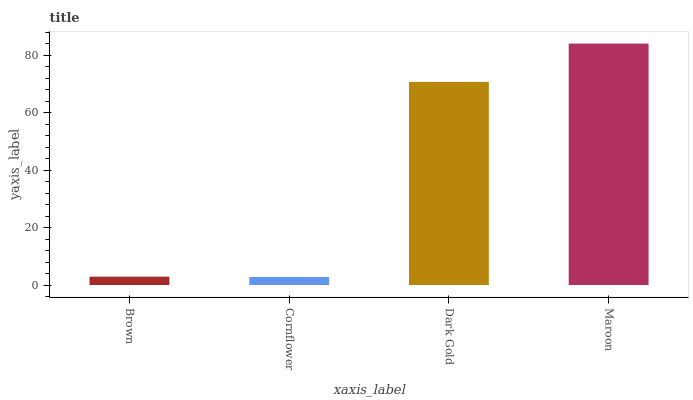Is Cornflower the minimum?
Answer yes or no. Yes. Is Maroon the maximum?
Answer yes or no. Yes. Is Dark Gold the minimum?
Answer yes or no. No. Is Dark Gold the maximum?
Answer yes or no. No. Is Dark Gold greater than Cornflower?
Answer yes or no. Yes. Is Cornflower less than Dark Gold?
Answer yes or no. Yes. Is Cornflower greater than Dark Gold?
Answer yes or no. No. Is Dark Gold less than Cornflower?
Answer yes or no. No. Is Dark Gold the high median?
Answer yes or no. Yes. Is Brown the low median?
Answer yes or no. Yes. Is Brown the high median?
Answer yes or no. No. Is Maroon the low median?
Answer yes or no. No. 